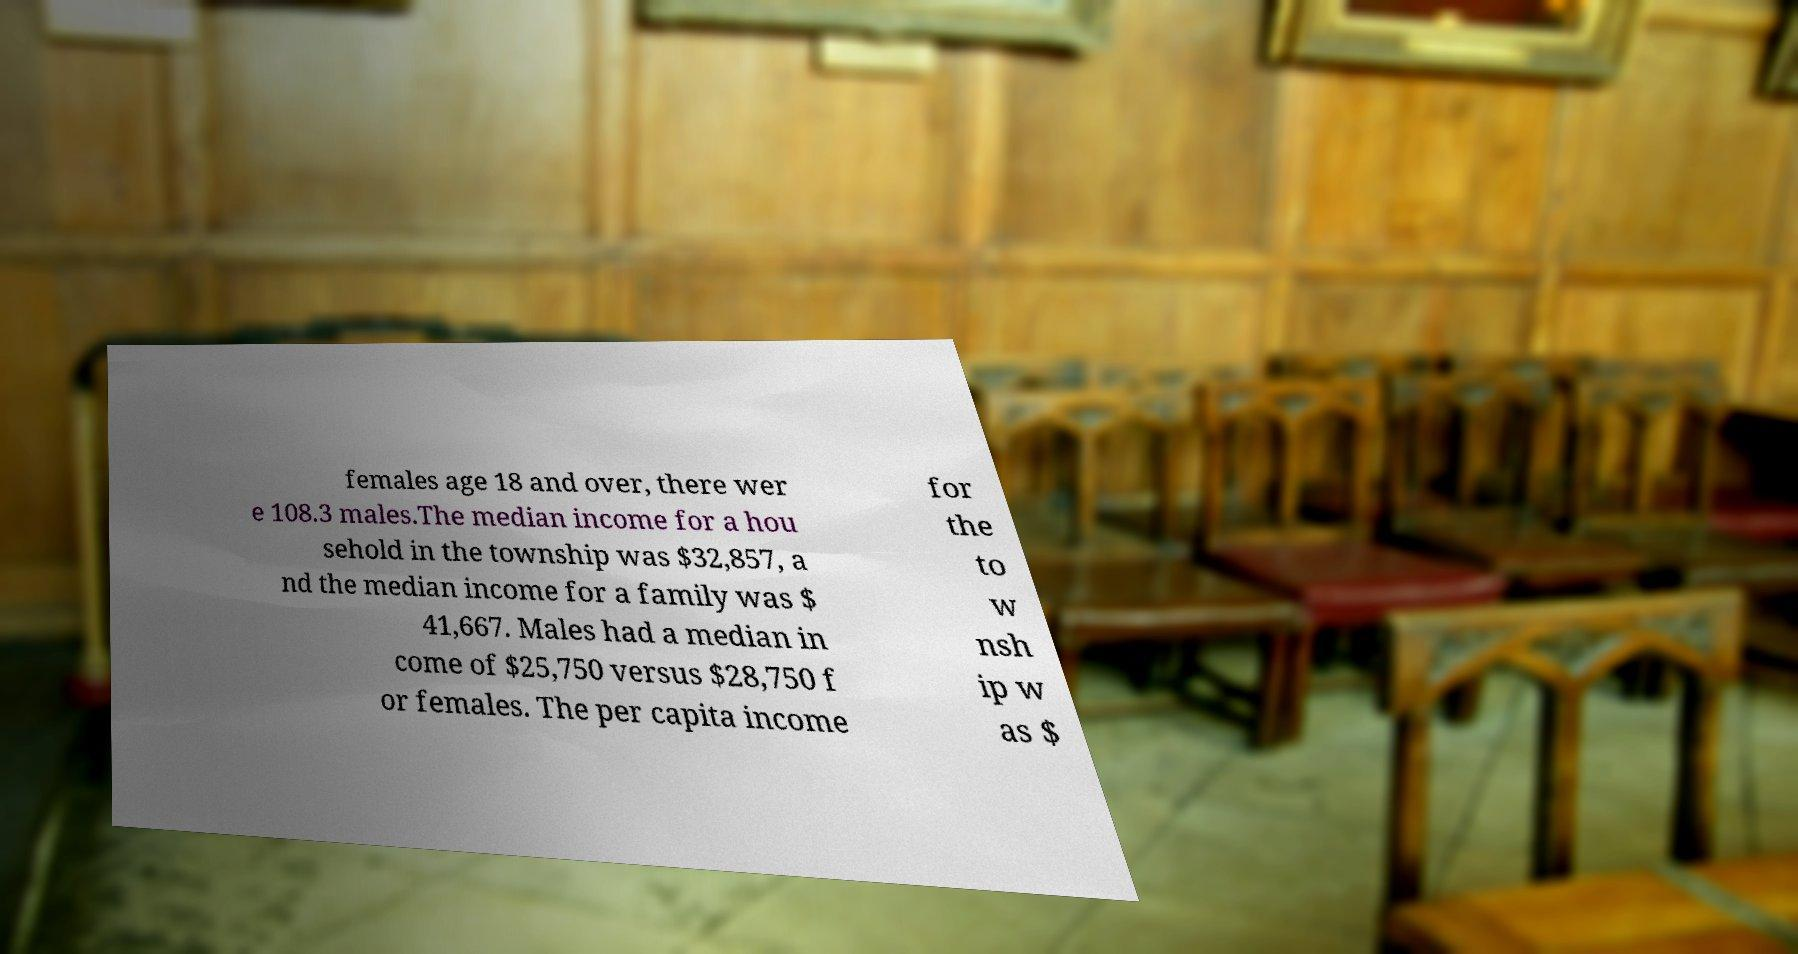What messages or text are displayed in this image? I need them in a readable, typed format. females age 18 and over, there wer e 108.3 males.The median income for a hou sehold in the township was $32,857, a nd the median income for a family was $ 41,667. Males had a median in come of $25,750 versus $28,750 f or females. The per capita income for the to w nsh ip w as $ 